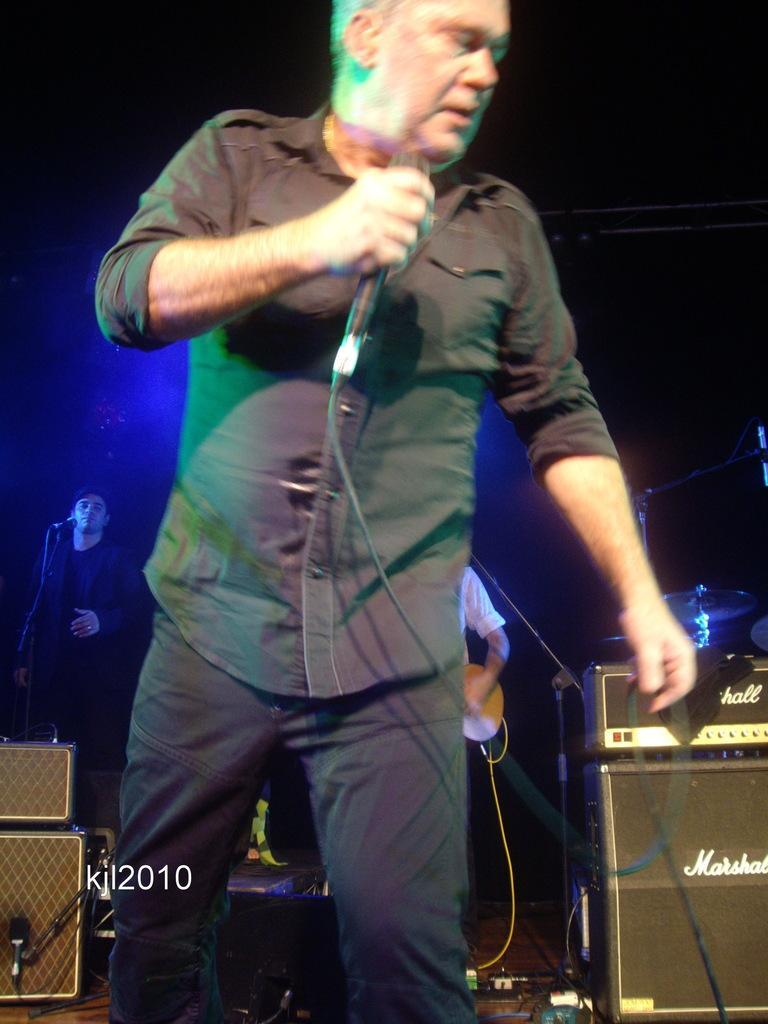Describe this image in one or two sentences. This is the picture of a person wearing black shirt and black pant and holding a mike and behind him there is a person who is standing in front of a mike and there are some speakers behind him. 